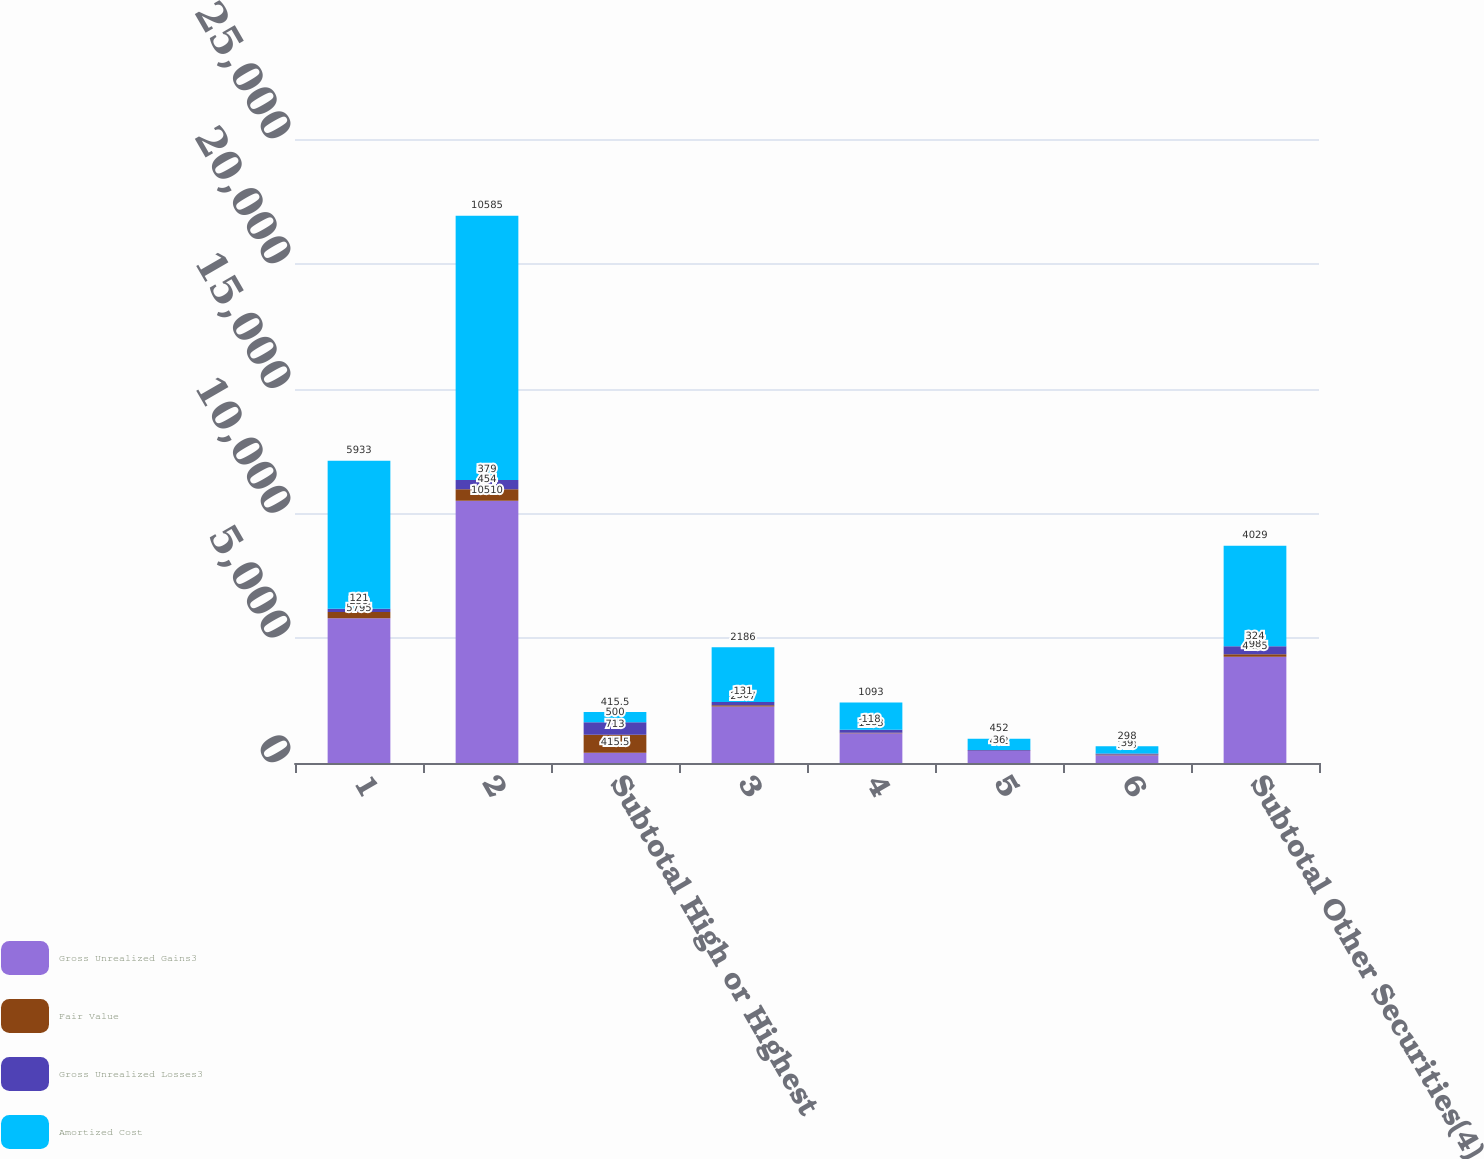Convert chart to OTSL. <chart><loc_0><loc_0><loc_500><loc_500><stacked_bar_chart><ecel><fcel>1<fcel>2<fcel>Subtotal High or Highest<fcel>3<fcel>4<fcel>5<fcel>6<fcel>Subtotal Other Securities(4)<nl><fcel>Gross Unrealized Gains3<fcel>5795<fcel>10510<fcel>415.5<fcel>2267<fcel>1193<fcel>482<fcel>313<fcel>4255<nl><fcel>Fair Value<fcel>259<fcel>454<fcel>713<fcel>50<fcel>18<fcel>6<fcel>24<fcel>98<nl><fcel>Gross Unrealized Losses3<fcel>121<fcel>379<fcel>500<fcel>131<fcel>118<fcel>36<fcel>39<fcel>324<nl><fcel>Amortized Cost<fcel>5933<fcel>10585<fcel>415.5<fcel>2186<fcel>1093<fcel>452<fcel>298<fcel>4029<nl></chart> 